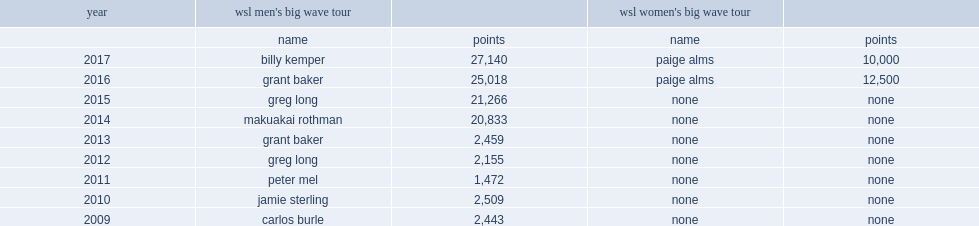How many points did makua rothman get? 20833.0. 